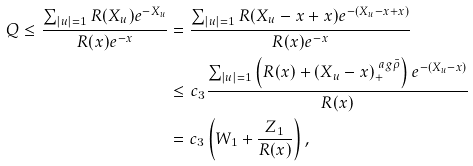Convert formula to latex. <formula><loc_0><loc_0><loc_500><loc_500>Q \leq \frac { \sum _ { | u | = 1 } R ( X _ { u } ) e ^ { - X _ { u } } } { R ( x ) e ^ { - x } } & = \frac { \sum _ { | u | = 1 } R ( X _ { u } - x + x ) e ^ { - ( X _ { u } - x + x ) } } { R ( x ) e ^ { - x } } \\ & \leq c _ { 3 } \frac { \sum _ { | u | = 1 } \left ( R ( x ) + ( X _ { u } - x ) ^ { \ a g \bar { \rho } } _ { + } \right ) e ^ { - ( X _ { u } - x ) } } { R ( x ) } \\ & = c _ { 3 } \left ( W _ { 1 } + \frac { Z _ { 1 } } { R ( x ) } \right ) ,</formula> 